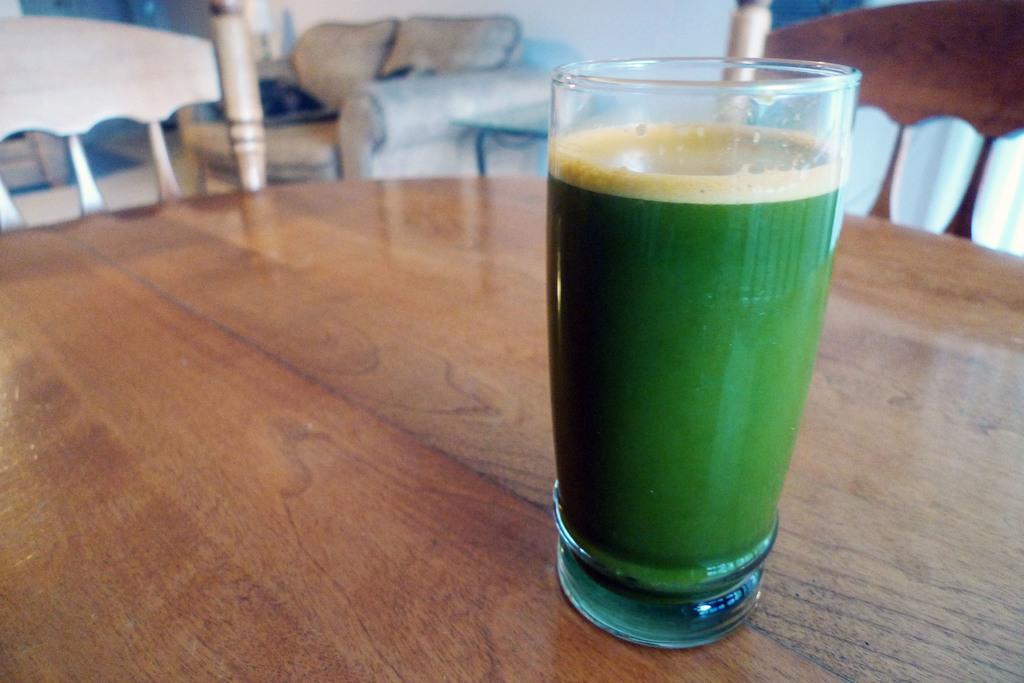Please provide a concise description of this image. In this image I see a glass in which there is green color liquid and this glass is on the brown color table and I see 2 chairs near to the table. In the background I see the couch over here and I see the wall which is of white in color. 